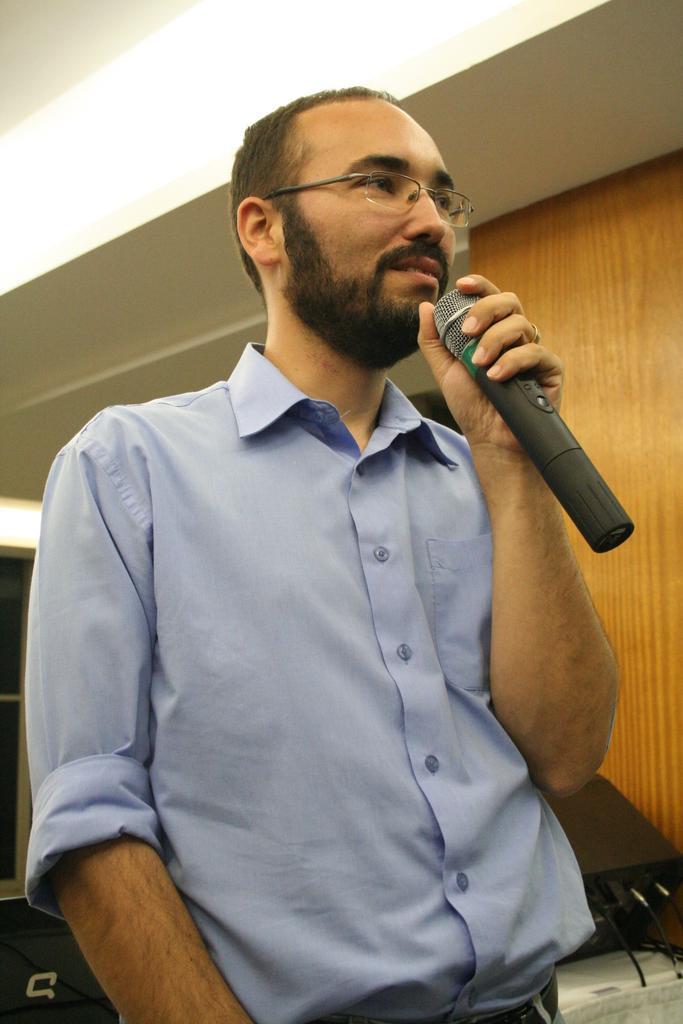How would you summarize this image in a sentence or two? There is a person holding a microphone in his hand. 